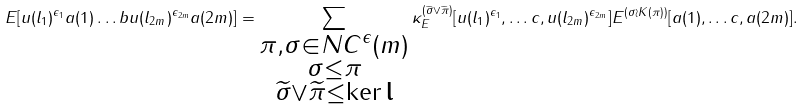<formula> <loc_0><loc_0><loc_500><loc_500>E [ u ( l _ { 1 } ) ^ { \epsilon _ { 1 } } a ( 1 ) \dots b u ( l _ { 2 m } ) ^ { \epsilon _ { 2 m } } a ( 2 m ) ] = \sum _ { \substack { \pi , \sigma \in N C ^ { \epsilon } ( m ) \\ \sigma \leq \pi \\ \widetilde { \sigma } \vee \widetilde { \pi } \leq \ker \mathbf l } } \kappa _ { E } ^ { ( \widetilde { \sigma } \vee \widetilde { \pi } ) } [ u ( l _ { 1 } ) ^ { \epsilon _ { 1 } } , \dots c , u ( l _ { 2 m } ) ^ { \epsilon _ { 2 m } } ] E ^ { ( \sigma \wr K ( \pi ) ) } [ a ( 1 ) , \dots c , a ( 2 m ) ] .</formula> 